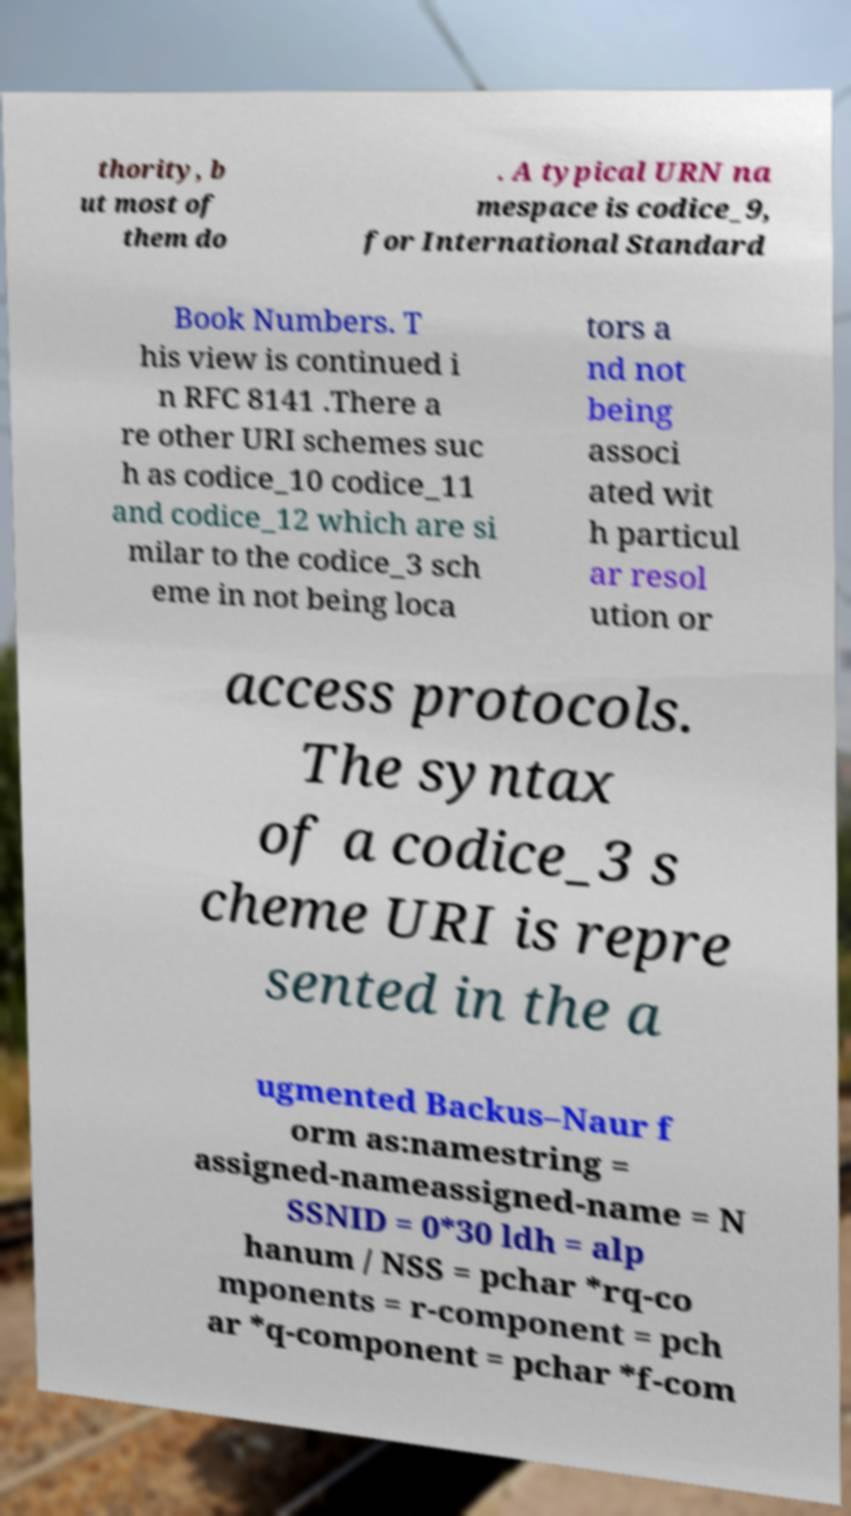Please identify and transcribe the text found in this image. thority, b ut most of them do . A typical URN na mespace is codice_9, for International Standard Book Numbers. T his view is continued i n RFC 8141 .There a re other URI schemes suc h as codice_10 codice_11 and codice_12 which are si milar to the codice_3 sch eme in not being loca tors a nd not being associ ated wit h particul ar resol ution or access protocols. The syntax of a codice_3 s cheme URI is repre sented in the a ugmented Backus–Naur f orm as:namestring = assigned-nameassigned-name = N SSNID = 0*30 ldh = alp hanum / NSS = pchar *rq-co mponents = r-component = pch ar *q-component = pchar *f-com 